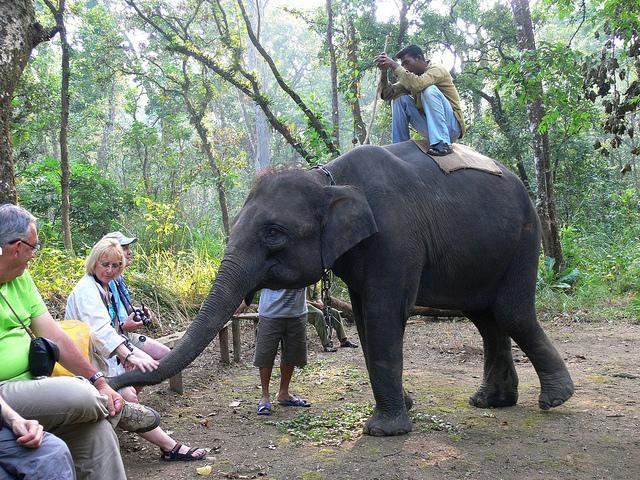How many people are riding the elephant?
Give a very brief answer. 1. How many people are there?
Give a very brief answer. 6. How many people are in front of the elephant?
Give a very brief answer. 4. How many women are here?
Give a very brief answer. 1. How many people are in the picture?
Give a very brief answer. 6. 